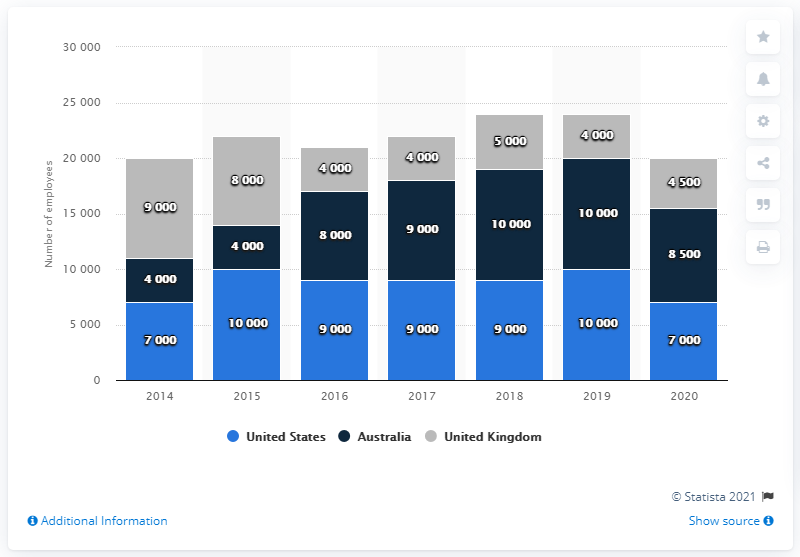Draw attention to some important aspects in this diagram. Approximately 8,500 employees were located in the United States. According to News Corp., approximately 8,500 of its employees are located in Australia. 